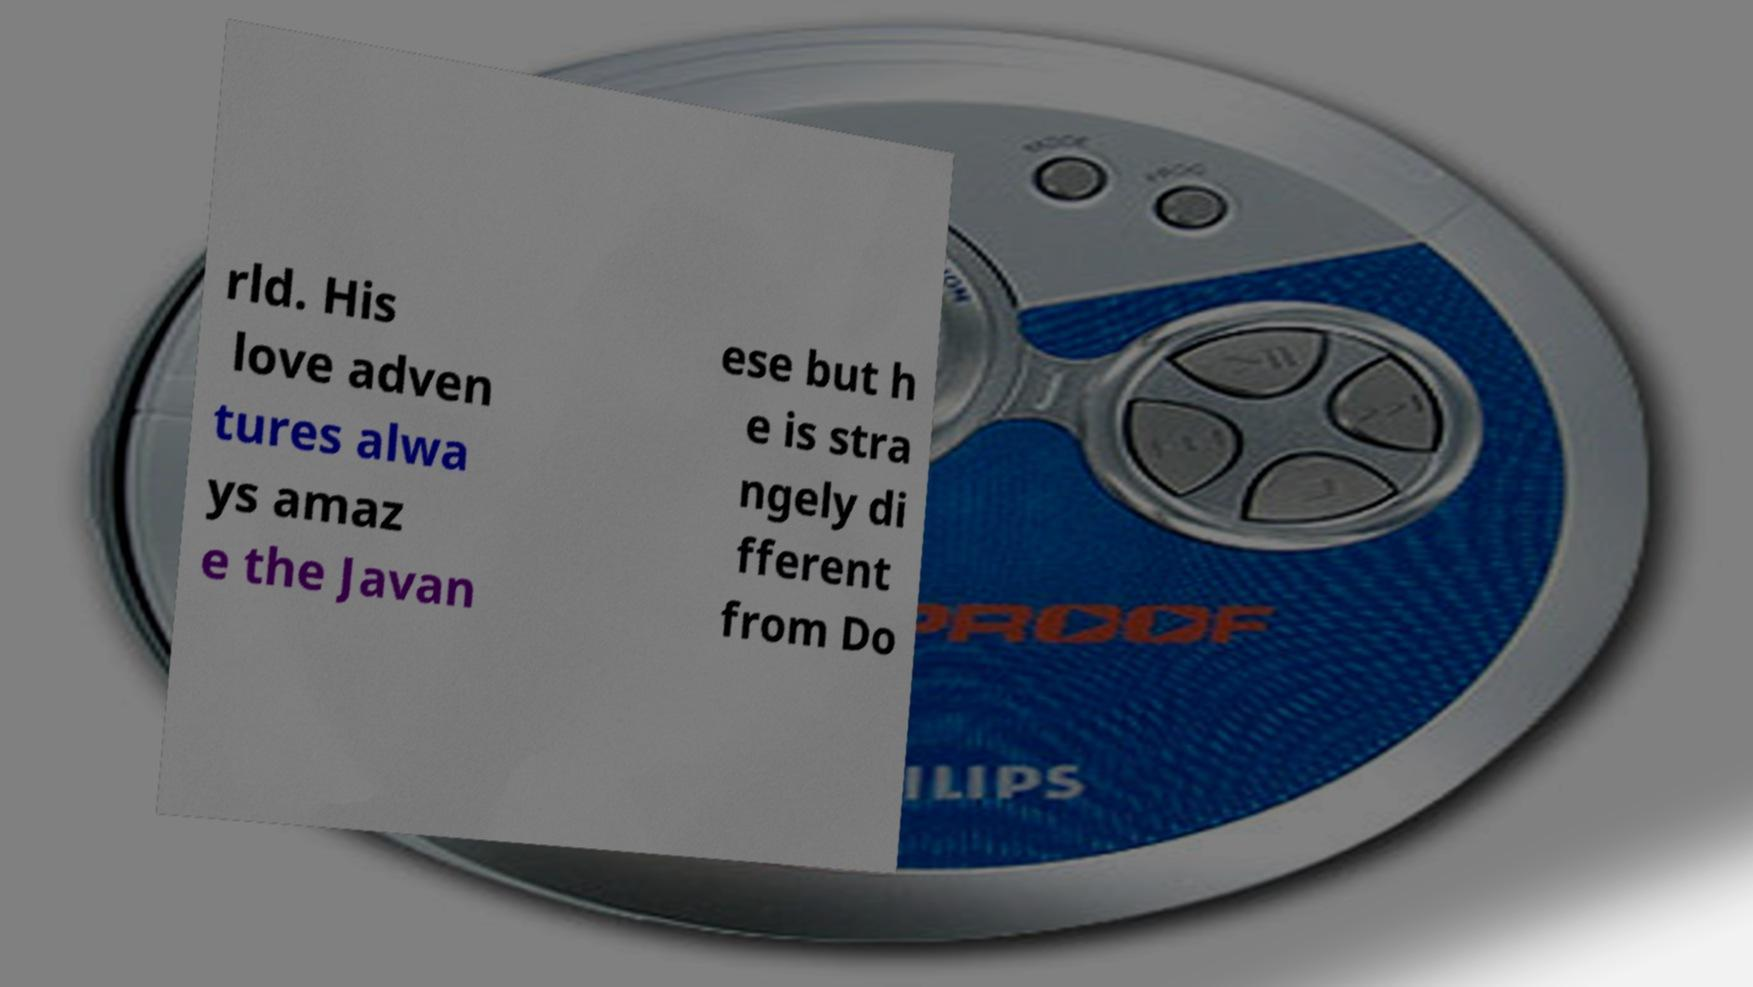Can you accurately transcribe the text from the provided image for me? rld. His love adven tures alwa ys amaz e the Javan ese but h e is stra ngely di fferent from Do 